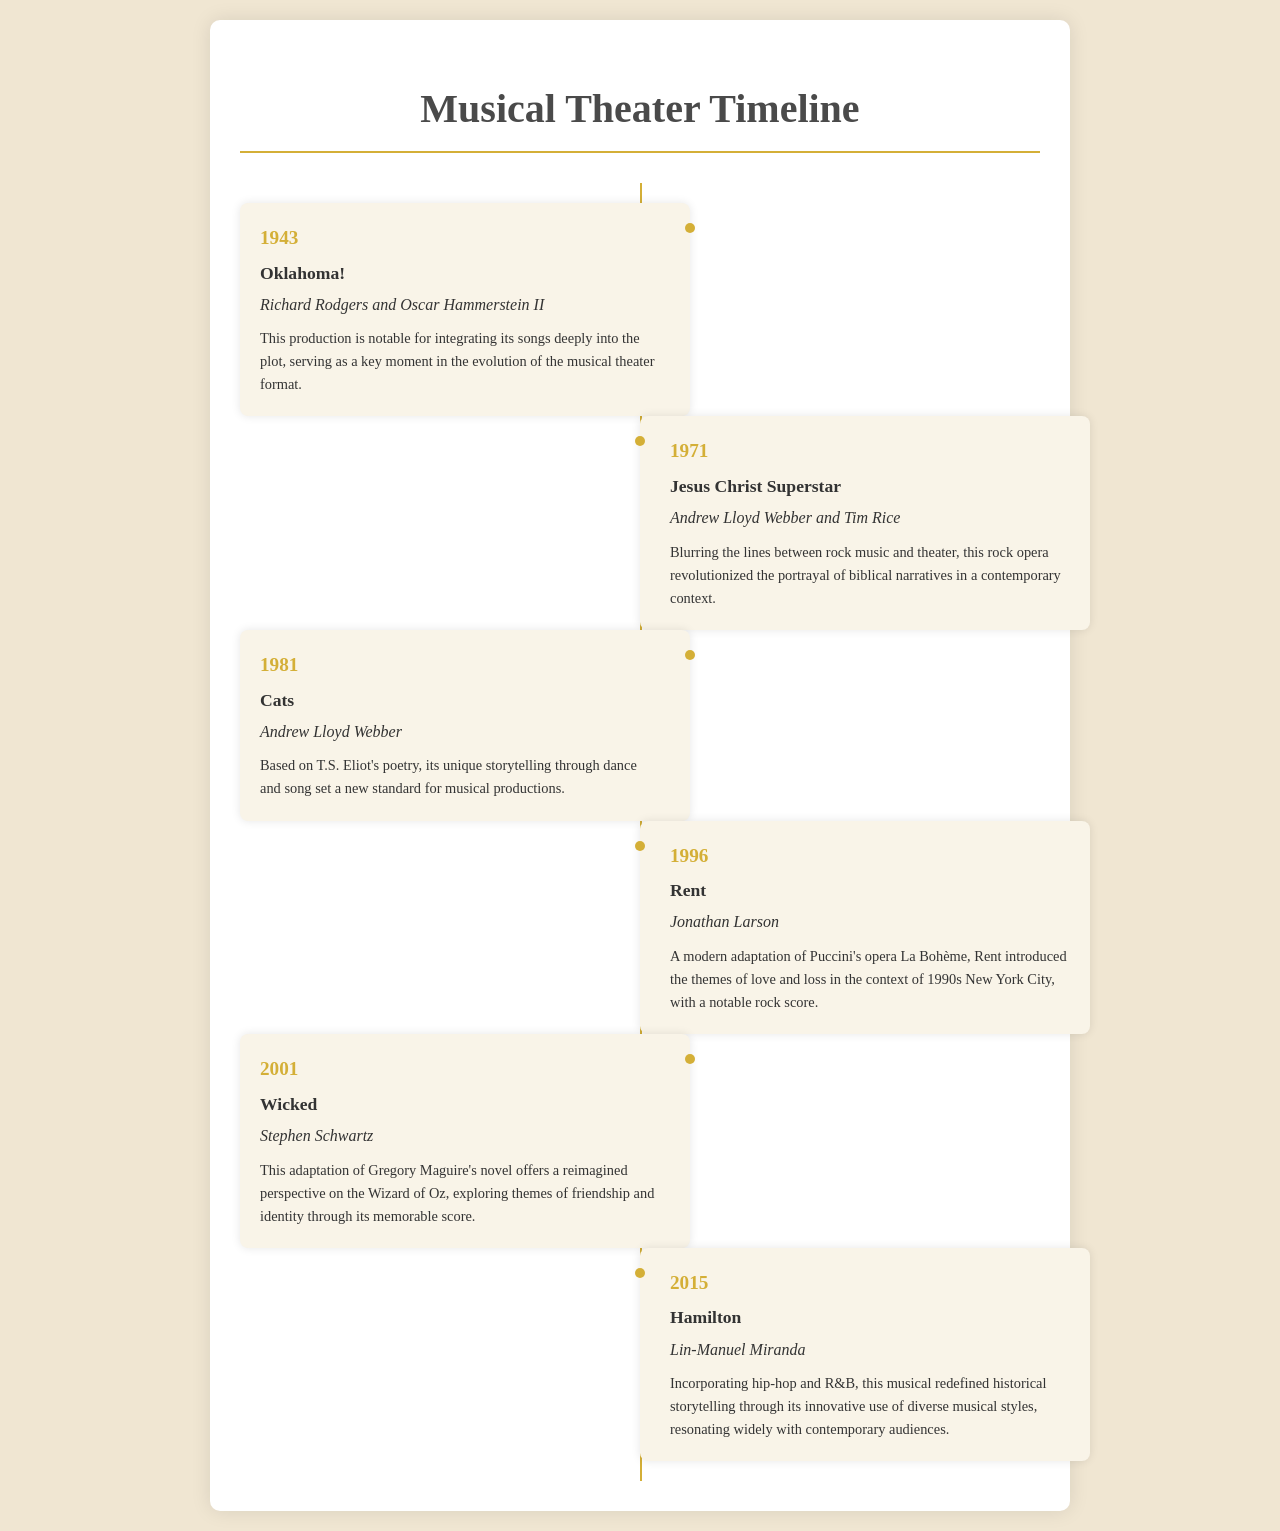What year did "Oklahoma!" premiere? The document states that "Oklahoma!" premiered in 1943.
Answer: 1943 Who composed the music for "Wicked"? According to the document, Stephen Schwartz composed the music for "Wicked".
Answer: Stephen Schwartz What is the significance of "Cats"? The document mentions that "Cats" set a new standard for musical productions through storytelling by dance and song.
Answer: Storytelling through dance and song In what year was "Hamilton" released? The timeline shows that "Hamilton" was released in 2015.
Answer: 2015 Which musical is known for integrating its songs deeply into the plot? The document states that "Oklahoma!" is notable for integrating its songs deeply into the plot.
Answer: Oklahoma! What genre does "Jesus Christ Superstar" represent? The document describes "Jesus Christ Superstar" as a rock opera, blurring lines between rock music and theater.
Answer: Rock opera What major themes does "Rent" explore? According to the document, "Rent" explores themes of love and loss.
Answer: Love and loss Which production is an adaptation of a novel by Gregory Maguire? The document indicates that "Wicked" is adapted from Gregory Maguire's novel.
Answer: Wicked Who are the composers of "Rent"? The document states that Jonathan Larson is the composer of "Rent".
Answer: Jonathan Larson 